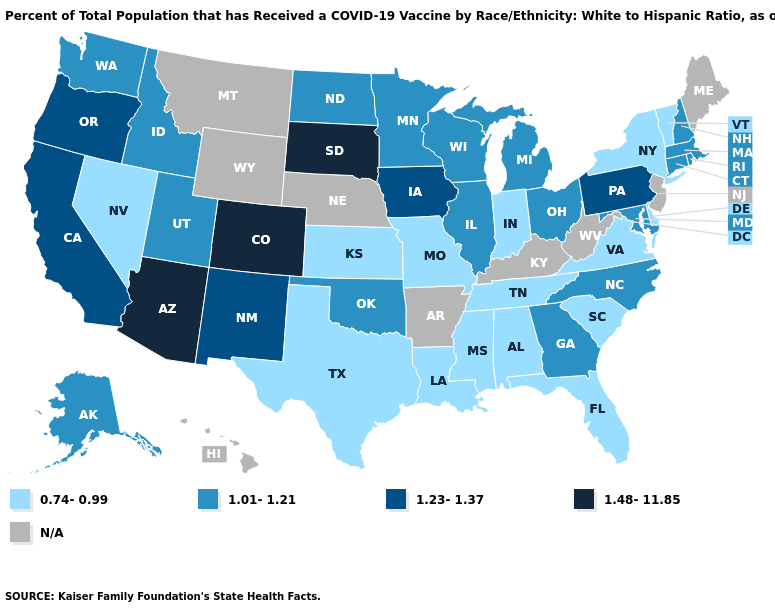Name the states that have a value in the range 0.74-0.99?
Quick response, please. Alabama, Delaware, Florida, Indiana, Kansas, Louisiana, Mississippi, Missouri, Nevada, New York, South Carolina, Tennessee, Texas, Vermont, Virginia. Which states have the lowest value in the MidWest?
Concise answer only. Indiana, Kansas, Missouri. Among the states that border Georgia , which have the highest value?
Write a very short answer. North Carolina. Which states hav the highest value in the South?
Write a very short answer. Georgia, Maryland, North Carolina, Oklahoma. Name the states that have a value in the range 1.48-11.85?
Concise answer only. Arizona, Colorado, South Dakota. What is the highest value in the USA?
Be succinct. 1.48-11.85. Among the states that border Arkansas , does Louisiana have the highest value?
Keep it brief. No. Which states hav the highest value in the South?
Concise answer only. Georgia, Maryland, North Carolina, Oklahoma. How many symbols are there in the legend?
Short answer required. 5. Among the states that border Arizona , which have the highest value?
Be succinct. Colorado. What is the value of Delaware?
Give a very brief answer. 0.74-0.99. Name the states that have a value in the range 1.23-1.37?
Keep it brief. California, Iowa, New Mexico, Oregon, Pennsylvania. Which states have the highest value in the USA?
Write a very short answer. Arizona, Colorado, South Dakota. 